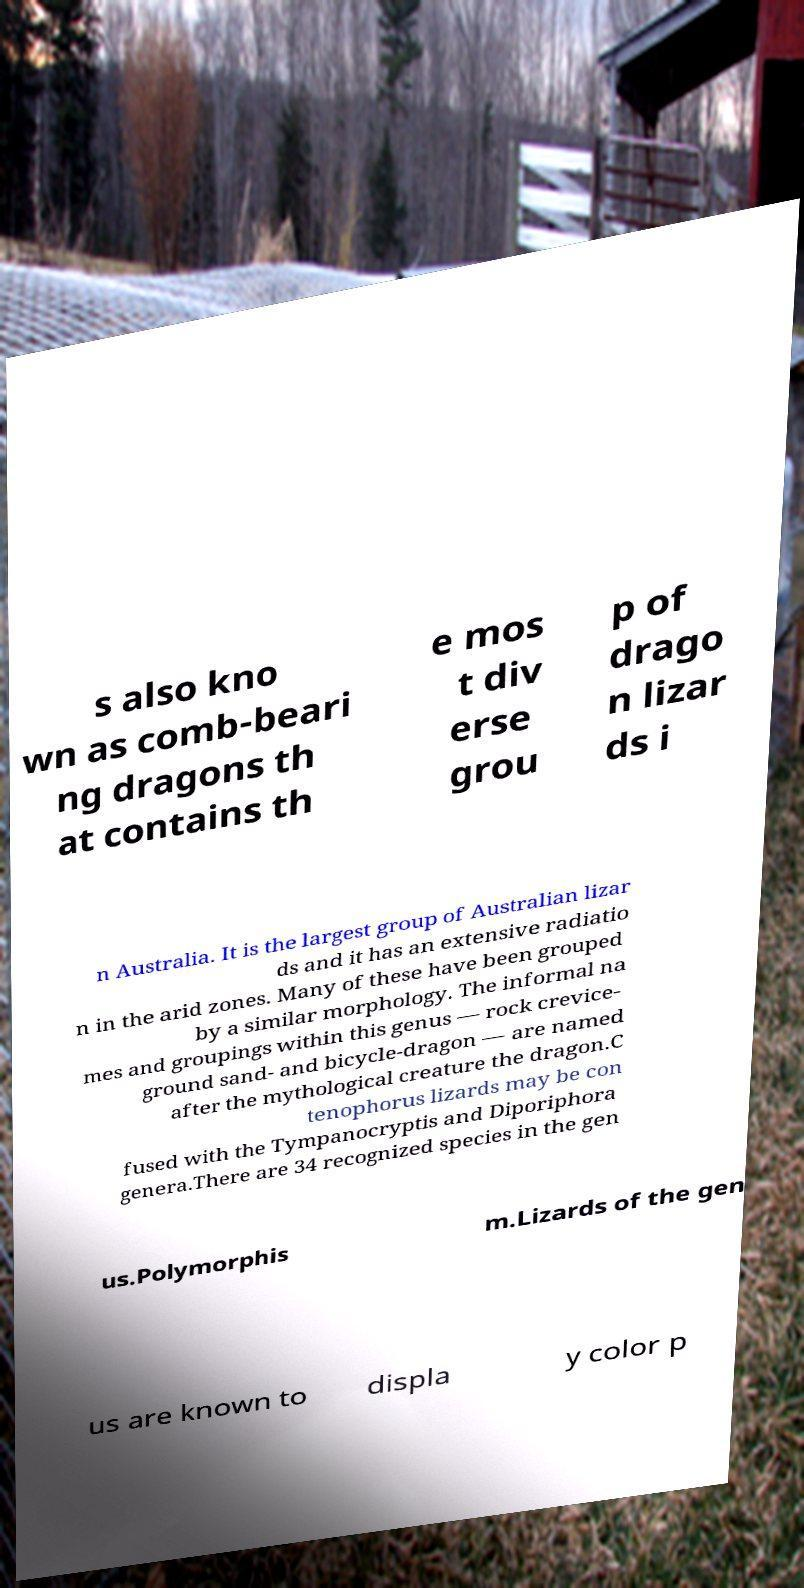Can you read and provide the text displayed in the image?This photo seems to have some interesting text. Can you extract and type it out for me? s also kno wn as comb-beari ng dragons th at contains th e mos t div erse grou p of drago n lizar ds i n Australia. It is the largest group of Australian lizar ds and it has an extensive radiatio n in the arid zones. Many of these have been grouped by a similar morphology. The informal na mes and groupings within this genus — rock crevice- ground sand- and bicycle-dragon — are named after the mythological creature the dragon.C tenophorus lizards may be con fused with the Tympanocryptis and Diporiphora genera.There are 34 recognized species in the gen us.Polymorphis m.Lizards of the gen us are known to displa y color p 